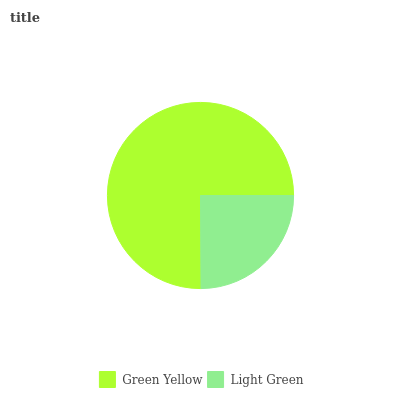Is Light Green the minimum?
Answer yes or no. Yes. Is Green Yellow the maximum?
Answer yes or no. Yes. Is Light Green the maximum?
Answer yes or no. No. Is Green Yellow greater than Light Green?
Answer yes or no. Yes. Is Light Green less than Green Yellow?
Answer yes or no. Yes. Is Light Green greater than Green Yellow?
Answer yes or no. No. Is Green Yellow less than Light Green?
Answer yes or no. No. Is Green Yellow the high median?
Answer yes or no. Yes. Is Light Green the low median?
Answer yes or no. Yes. Is Light Green the high median?
Answer yes or no. No. Is Green Yellow the low median?
Answer yes or no. No. 